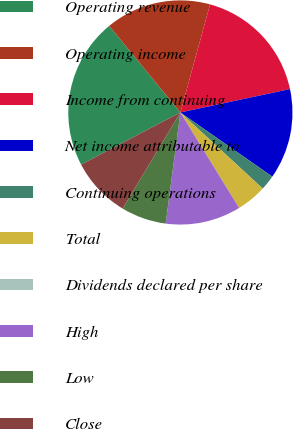<chart> <loc_0><loc_0><loc_500><loc_500><pie_chart><fcel>Operating revenue<fcel>Operating income<fcel>Income from continuing<fcel>Net income attributable to<fcel>Continuing operations<fcel>Total<fcel>Dividends declared per share<fcel>High<fcel>Low<fcel>Close<nl><fcel>21.74%<fcel>15.22%<fcel>17.39%<fcel>13.04%<fcel>2.18%<fcel>4.35%<fcel>0.0%<fcel>10.87%<fcel>6.52%<fcel>8.7%<nl></chart> 